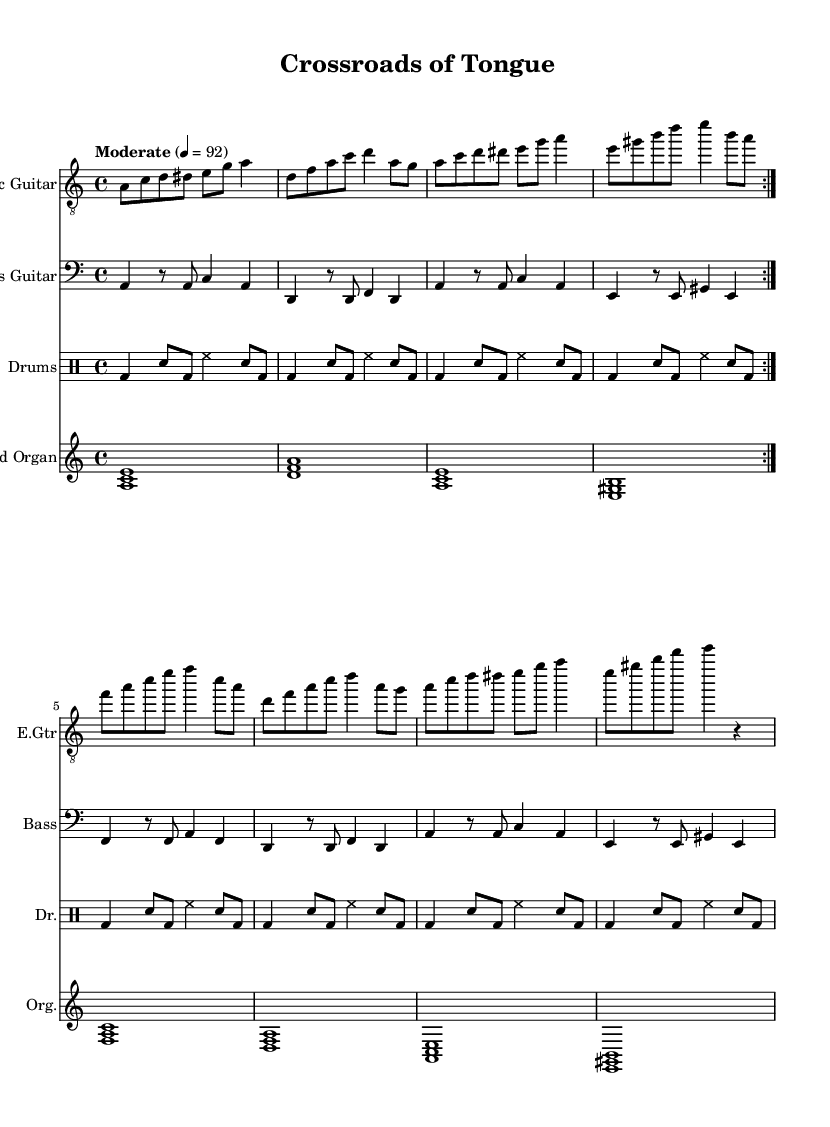What is the key signature of this music? The key signature is A minor, which contains no sharps or flats. This can be determined by looking at the key signature notated at the beginning of the score.
Answer: A minor What is the time signature of this piece? The time signature is 4/4, indicated at the beginning of the score in the staff. This means there are four beats in a measure, and each quarter note gets one beat.
Answer: 4/4 What is the tempo marking of the music? The tempo marking indicates "Moderate" at a speed of 92 beats per minute, which is stated at the beginning of the score. This guides the performer on the pace of the music.
Answer: Moderate 4 = 92 How many measures are in the first section of the electric guitar part? The first section of the electric guitar part, which is repeated twice, consists of 8 measures: 4 measures before the repeat sign, and another 4 in the repeat.
Answer: 8 What is the primary instrument in this piece? The primary instrument featured in this piece is the Electric Guitar, as it is listed first in the score and carries the main melody.
Answer: Electric Guitar What chord progression is primarily used in the organ part? The organ part follows a pattern of chords that reflect common blues progressions, primarily using the chords A minor, D minor, and E major. This is typical for electric blues music, emphasizing the cultural and linguistic aspects of the genre.
Answer: A minor, D minor, E major What rhythm is most prevalent in the drum part? The drum part features a combination of bass drum and snare hits with a steady eighth-note rhythm, which is characteristic of electric blues drumming styles that support the groove of the music.
Answer: Eighth-note rhythm 